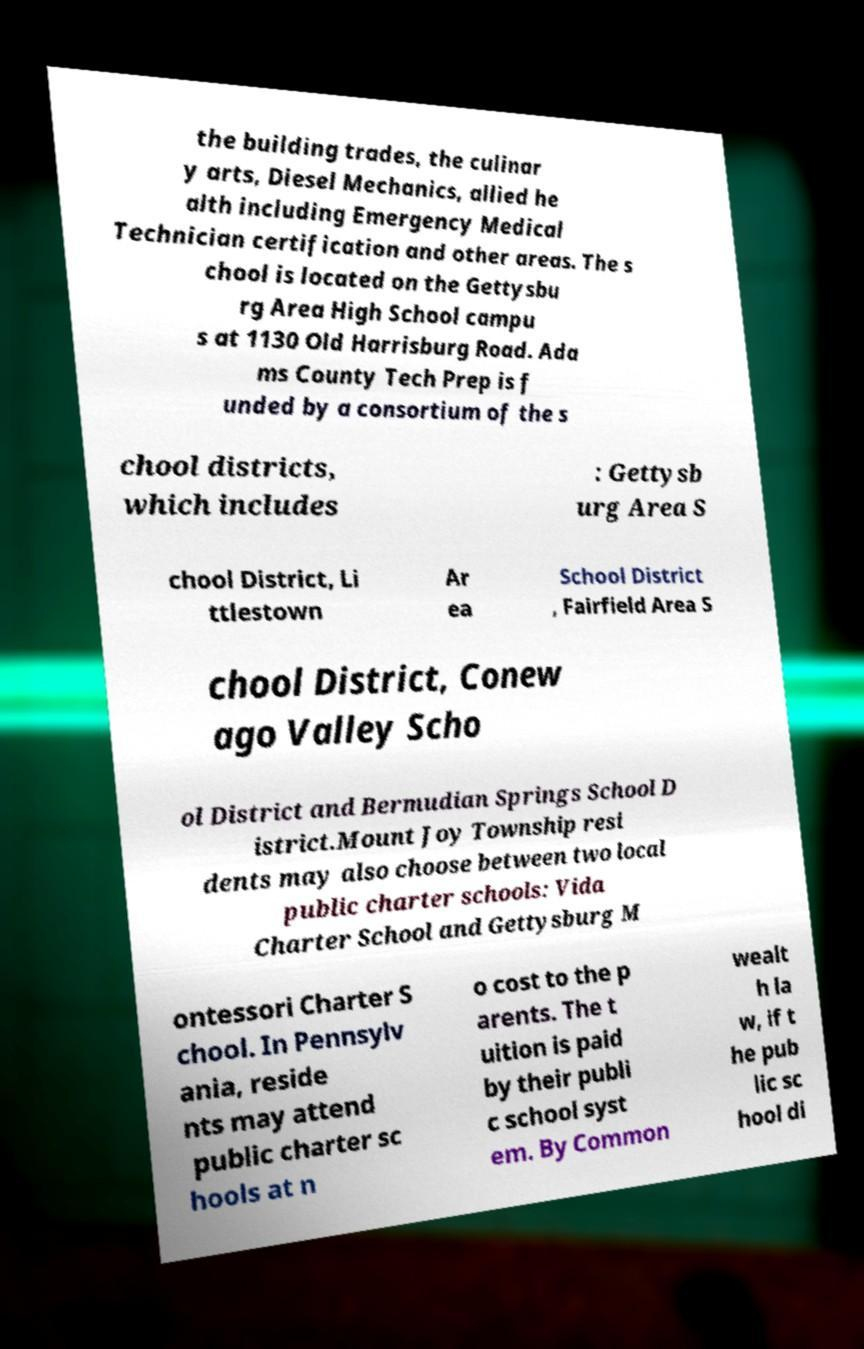Can you accurately transcribe the text from the provided image for me? the building trades, the culinar y arts, Diesel Mechanics, allied he alth including Emergency Medical Technician certification and other areas. The s chool is located on the Gettysbu rg Area High School campu s at 1130 Old Harrisburg Road. Ada ms County Tech Prep is f unded by a consortium of the s chool districts, which includes : Gettysb urg Area S chool District, Li ttlestown Ar ea School District , Fairfield Area S chool District, Conew ago Valley Scho ol District and Bermudian Springs School D istrict.Mount Joy Township resi dents may also choose between two local public charter schools: Vida Charter School and Gettysburg M ontessori Charter S chool. In Pennsylv ania, reside nts may attend public charter sc hools at n o cost to the p arents. The t uition is paid by their publi c school syst em. By Common wealt h la w, if t he pub lic sc hool di 